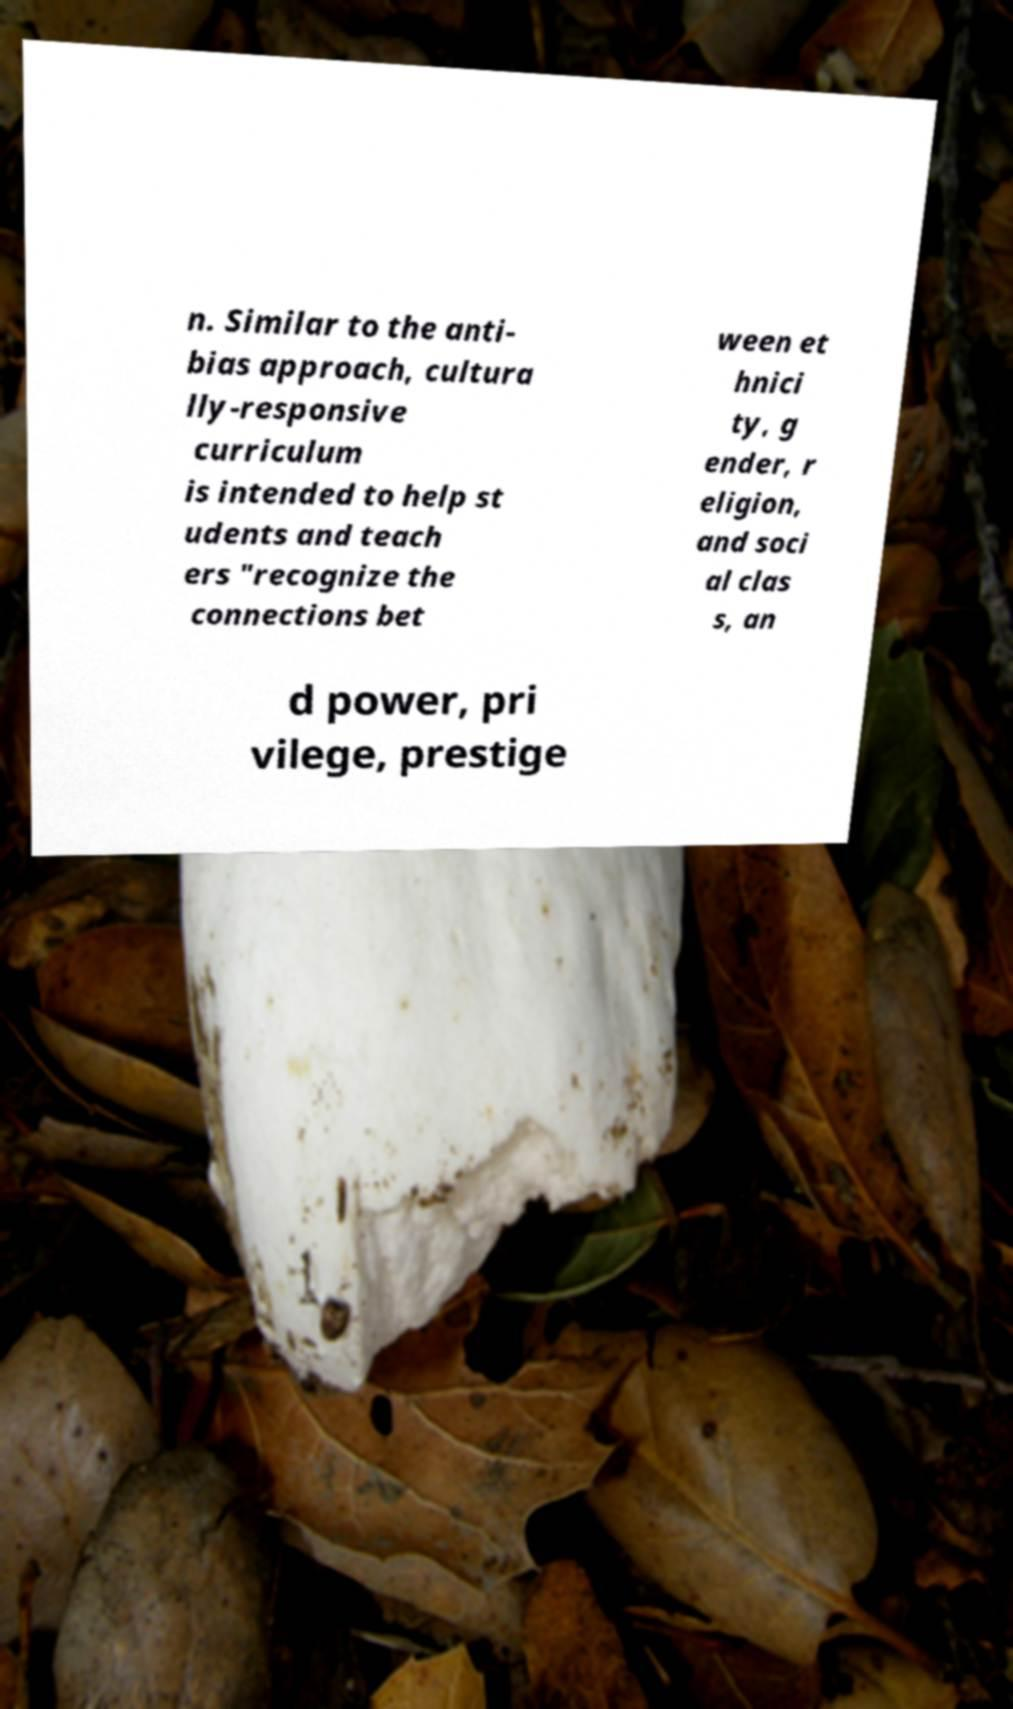Please identify and transcribe the text found in this image. n. Similar to the anti- bias approach, cultura lly-responsive curriculum is intended to help st udents and teach ers "recognize the connections bet ween et hnici ty, g ender, r eligion, and soci al clas s, an d power, pri vilege, prestige 